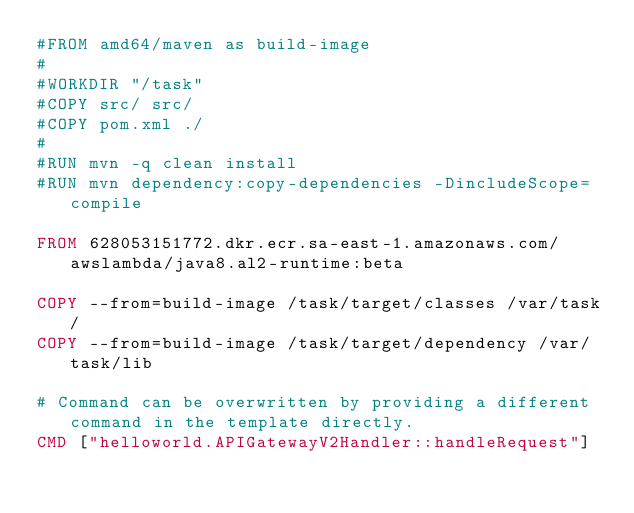Convert code to text. <code><loc_0><loc_0><loc_500><loc_500><_Dockerfile_>#FROM amd64/maven as build-image
#
#WORKDIR "/task"
#COPY src/ src/
#COPY pom.xml ./
#
#RUN mvn -q clean install
#RUN mvn dependency:copy-dependencies -DincludeScope=compile

FROM 628053151772.dkr.ecr.sa-east-1.amazonaws.com/awslambda/java8.al2-runtime:beta

COPY --from=build-image /task/target/classes /var/task/
COPY --from=build-image /task/target/dependency /var/task/lib

# Command can be overwritten by providing a different command in the template directly.
CMD ["helloworld.APIGatewayV2Handler::handleRequest"]</code> 